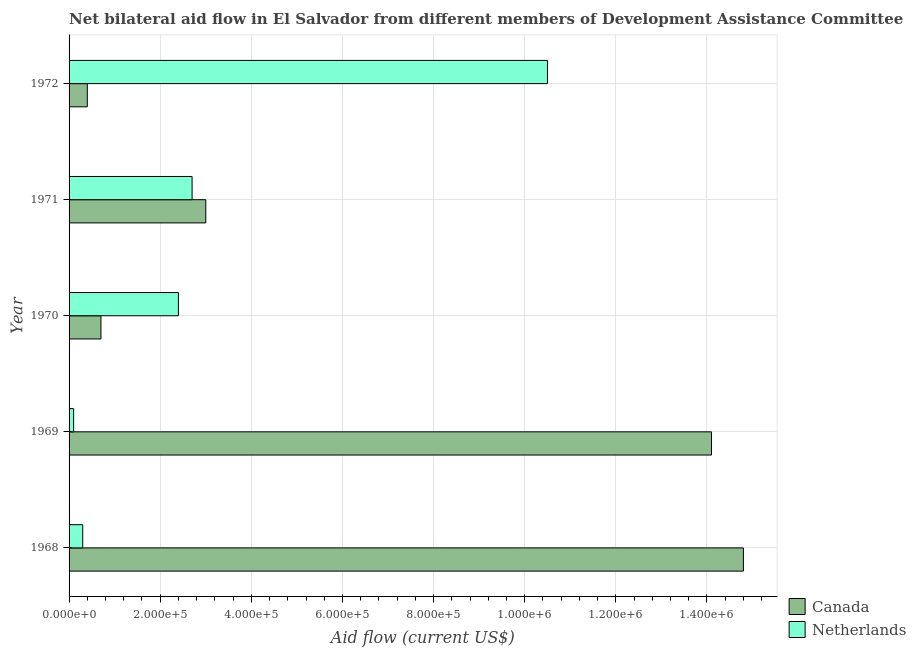How many different coloured bars are there?
Offer a terse response. 2. How many groups of bars are there?
Keep it short and to the point. 5. Are the number of bars per tick equal to the number of legend labels?
Provide a short and direct response. Yes. How many bars are there on the 4th tick from the top?
Your answer should be very brief. 2. How many bars are there on the 2nd tick from the bottom?
Your answer should be compact. 2. What is the label of the 4th group of bars from the top?
Provide a short and direct response. 1969. In how many cases, is the number of bars for a given year not equal to the number of legend labels?
Your response must be concise. 0. What is the amount of aid given by canada in 1969?
Offer a terse response. 1.41e+06. Across all years, what is the maximum amount of aid given by netherlands?
Give a very brief answer. 1.05e+06. Across all years, what is the minimum amount of aid given by canada?
Keep it short and to the point. 4.00e+04. In which year was the amount of aid given by netherlands maximum?
Ensure brevity in your answer.  1972. In which year was the amount of aid given by netherlands minimum?
Your answer should be very brief. 1969. What is the total amount of aid given by netherlands in the graph?
Keep it short and to the point. 1.60e+06. What is the difference between the amount of aid given by canada in 1968 and that in 1971?
Give a very brief answer. 1.18e+06. What is the difference between the amount of aid given by netherlands in 1968 and the amount of aid given by canada in 1972?
Keep it short and to the point. -10000. What is the average amount of aid given by netherlands per year?
Your answer should be very brief. 3.20e+05. In the year 1971, what is the difference between the amount of aid given by canada and amount of aid given by netherlands?
Offer a terse response. 3.00e+04. In how many years, is the amount of aid given by canada greater than 680000 US$?
Make the answer very short. 2. What is the ratio of the amount of aid given by canada in 1968 to that in 1969?
Offer a very short reply. 1.05. Is the amount of aid given by canada in 1970 less than that in 1971?
Keep it short and to the point. Yes. What is the difference between the highest and the lowest amount of aid given by canada?
Give a very brief answer. 1.44e+06. In how many years, is the amount of aid given by canada greater than the average amount of aid given by canada taken over all years?
Your answer should be very brief. 2. What does the 2nd bar from the top in 1972 represents?
Provide a succinct answer. Canada. What does the 2nd bar from the bottom in 1970 represents?
Provide a short and direct response. Netherlands. How many bars are there?
Your answer should be compact. 10. How many years are there in the graph?
Offer a very short reply. 5. Does the graph contain any zero values?
Your response must be concise. No. Does the graph contain grids?
Offer a terse response. Yes. How are the legend labels stacked?
Offer a terse response. Vertical. What is the title of the graph?
Provide a short and direct response. Net bilateral aid flow in El Salvador from different members of Development Assistance Committee. Does "Subsidies" appear as one of the legend labels in the graph?
Give a very brief answer. No. What is the label or title of the X-axis?
Offer a terse response. Aid flow (current US$). What is the Aid flow (current US$) in Canada in 1968?
Provide a succinct answer. 1.48e+06. What is the Aid flow (current US$) of Canada in 1969?
Give a very brief answer. 1.41e+06. What is the Aid flow (current US$) of Netherlands in 1969?
Make the answer very short. 10000. What is the Aid flow (current US$) in Netherlands in 1970?
Your response must be concise. 2.40e+05. What is the Aid flow (current US$) in Netherlands in 1971?
Provide a succinct answer. 2.70e+05. What is the Aid flow (current US$) of Netherlands in 1972?
Your response must be concise. 1.05e+06. Across all years, what is the maximum Aid flow (current US$) in Canada?
Your answer should be very brief. 1.48e+06. Across all years, what is the maximum Aid flow (current US$) of Netherlands?
Make the answer very short. 1.05e+06. Across all years, what is the minimum Aid flow (current US$) in Canada?
Your answer should be compact. 4.00e+04. Across all years, what is the minimum Aid flow (current US$) of Netherlands?
Give a very brief answer. 10000. What is the total Aid flow (current US$) in Canada in the graph?
Your response must be concise. 3.30e+06. What is the total Aid flow (current US$) in Netherlands in the graph?
Make the answer very short. 1.60e+06. What is the difference between the Aid flow (current US$) in Canada in 1968 and that in 1969?
Ensure brevity in your answer.  7.00e+04. What is the difference between the Aid flow (current US$) of Canada in 1968 and that in 1970?
Your answer should be very brief. 1.41e+06. What is the difference between the Aid flow (current US$) in Netherlands in 1968 and that in 1970?
Your answer should be very brief. -2.10e+05. What is the difference between the Aid flow (current US$) in Canada in 1968 and that in 1971?
Make the answer very short. 1.18e+06. What is the difference between the Aid flow (current US$) in Canada in 1968 and that in 1972?
Give a very brief answer. 1.44e+06. What is the difference between the Aid flow (current US$) of Netherlands in 1968 and that in 1972?
Offer a terse response. -1.02e+06. What is the difference between the Aid flow (current US$) of Canada in 1969 and that in 1970?
Offer a very short reply. 1.34e+06. What is the difference between the Aid flow (current US$) in Canada in 1969 and that in 1971?
Give a very brief answer. 1.11e+06. What is the difference between the Aid flow (current US$) in Canada in 1969 and that in 1972?
Give a very brief answer. 1.37e+06. What is the difference between the Aid flow (current US$) in Netherlands in 1969 and that in 1972?
Keep it short and to the point. -1.04e+06. What is the difference between the Aid flow (current US$) in Canada in 1970 and that in 1971?
Ensure brevity in your answer.  -2.30e+05. What is the difference between the Aid flow (current US$) in Netherlands in 1970 and that in 1971?
Provide a short and direct response. -3.00e+04. What is the difference between the Aid flow (current US$) of Canada in 1970 and that in 1972?
Give a very brief answer. 3.00e+04. What is the difference between the Aid flow (current US$) of Netherlands in 1970 and that in 1972?
Your answer should be compact. -8.10e+05. What is the difference between the Aid flow (current US$) of Netherlands in 1971 and that in 1972?
Ensure brevity in your answer.  -7.80e+05. What is the difference between the Aid flow (current US$) of Canada in 1968 and the Aid flow (current US$) of Netherlands in 1969?
Offer a very short reply. 1.47e+06. What is the difference between the Aid flow (current US$) in Canada in 1968 and the Aid flow (current US$) in Netherlands in 1970?
Your answer should be compact. 1.24e+06. What is the difference between the Aid flow (current US$) in Canada in 1968 and the Aid flow (current US$) in Netherlands in 1971?
Your response must be concise. 1.21e+06. What is the difference between the Aid flow (current US$) in Canada in 1968 and the Aid flow (current US$) in Netherlands in 1972?
Your answer should be very brief. 4.30e+05. What is the difference between the Aid flow (current US$) in Canada in 1969 and the Aid flow (current US$) in Netherlands in 1970?
Your answer should be compact. 1.17e+06. What is the difference between the Aid flow (current US$) of Canada in 1969 and the Aid flow (current US$) of Netherlands in 1971?
Make the answer very short. 1.14e+06. What is the difference between the Aid flow (current US$) of Canada in 1970 and the Aid flow (current US$) of Netherlands in 1972?
Provide a short and direct response. -9.80e+05. What is the difference between the Aid flow (current US$) of Canada in 1971 and the Aid flow (current US$) of Netherlands in 1972?
Your answer should be very brief. -7.50e+05. What is the average Aid flow (current US$) in Canada per year?
Provide a succinct answer. 6.60e+05. In the year 1968, what is the difference between the Aid flow (current US$) of Canada and Aid flow (current US$) of Netherlands?
Keep it short and to the point. 1.45e+06. In the year 1969, what is the difference between the Aid flow (current US$) of Canada and Aid flow (current US$) of Netherlands?
Your answer should be very brief. 1.40e+06. In the year 1971, what is the difference between the Aid flow (current US$) in Canada and Aid flow (current US$) in Netherlands?
Provide a short and direct response. 3.00e+04. In the year 1972, what is the difference between the Aid flow (current US$) in Canada and Aid flow (current US$) in Netherlands?
Give a very brief answer. -1.01e+06. What is the ratio of the Aid flow (current US$) of Canada in 1968 to that in 1969?
Provide a succinct answer. 1.05. What is the ratio of the Aid flow (current US$) in Netherlands in 1968 to that in 1969?
Offer a terse response. 3. What is the ratio of the Aid flow (current US$) of Canada in 1968 to that in 1970?
Offer a terse response. 21.14. What is the ratio of the Aid flow (current US$) of Netherlands in 1968 to that in 1970?
Give a very brief answer. 0.12. What is the ratio of the Aid flow (current US$) in Canada in 1968 to that in 1971?
Give a very brief answer. 4.93. What is the ratio of the Aid flow (current US$) of Canada in 1968 to that in 1972?
Offer a very short reply. 37. What is the ratio of the Aid flow (current US$) in Netherlands in 1968 to that in 1972?
Provide a short and direct response. 0.03. What is the ratio of the Aid flow (current US$) of Canada in 1969 to that in 1970?
Give a very brief answer. 20.14. What is the ratio of the Aid flow (current US$) of Netherlands in 1969 to that in 1970?
Make the answer very short. 0.04. What is the ratio of the Aid flow (current US$) of Netherlands in 1969 to that in 1971?
Keep it short and to the point. 0.04. What is the ratio of the Aid flow (current US$) of Canada in 1969 to that in 1972?
Your answer should be compact. 35.25. What is the ratio of the Aid flow (current US$) of Netherlands in 1969 to that in 1972?
Make the answer very short. 0.01. What is the ratio of the Aid flow (current US$) in Canada in 1970 to that in 1971?
Give a very brief answer. 0.23. What is the ratio of the Aid flow (current US$) of Netherlands in 1970 to that in 1972?
Your response must be concise. 0.23. What is the ratio of the Aid flow (current US$) of Netherlands in 1971 to that in 1972?
Give a very brief answer. 0.26. What is the difference between the highest and the second highest Aid flow (current US$) in Canada?
Your answer should be compact. 7.00e+04. What is the difference between the highest and the second highest Aid flow (current US$) in Netherlands?
Provide a succinct answer. 7.80e+05. What is the difference between the highest and the lowest Aid flow (current US$) in Canada?
Keep it short and to the point. 1.44e+06. What is the difference between the highest and the lowest Aid flow (current US$) in Netherlands?
Your answer should be compact. 1.04e+06. 